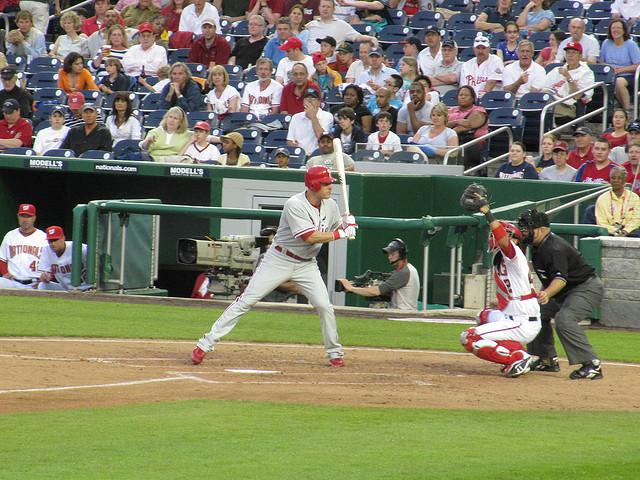Where is the ball? catcher's glove 